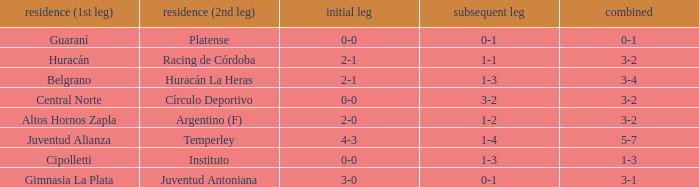Which team played the 2nd leg at home with a tie of 1-1 and scored 3-2 in aggregate? Racing de Córdoba. 